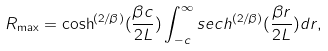<formula> <loc_0><loc_0><loc_500><loc_500>R _ { \max } = \cosh ^ { ( 2 / \beta ) } ( \frac { \beta c } { 2 L } ) \int _ { - c } ^ { \infty } s e c h ^ { ( 2 / \beta ) } ( \frac { \beta r } { 2 L } ) d r ,</formula> 